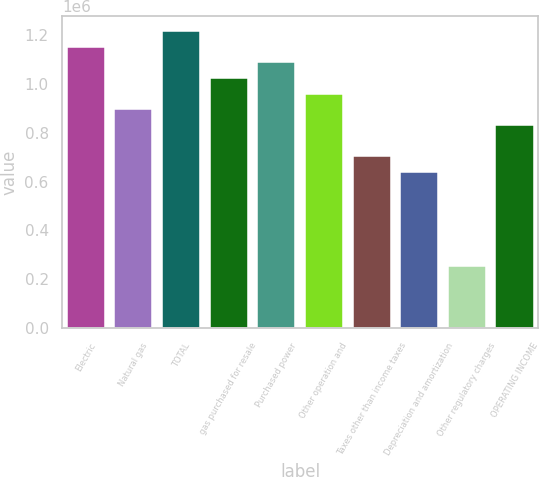Convert chart. <chart><loc_0><loc_0><loc_500><loc_500><bar_chart><fcel>Electric<fcel>Natural gas<fcel>TOTAL<fcel>gas purchased for resale<fcel>Purchased power<fcel>Other operation and<fcel>Taxes other than income taxes<fcel>Depreciation and amortization<fcel>Other regulatory charges<fcel>OPERATING INCOME<nl><fcel>1.15268e+06<fcel>896552<fcel>1.21671e+06<fcel>1.02462e+06<fcel>1.08865e+06<fcel>960584<fcel>704454<fcel>640422<fcel>256228<fcel>832519<nl></chart> 